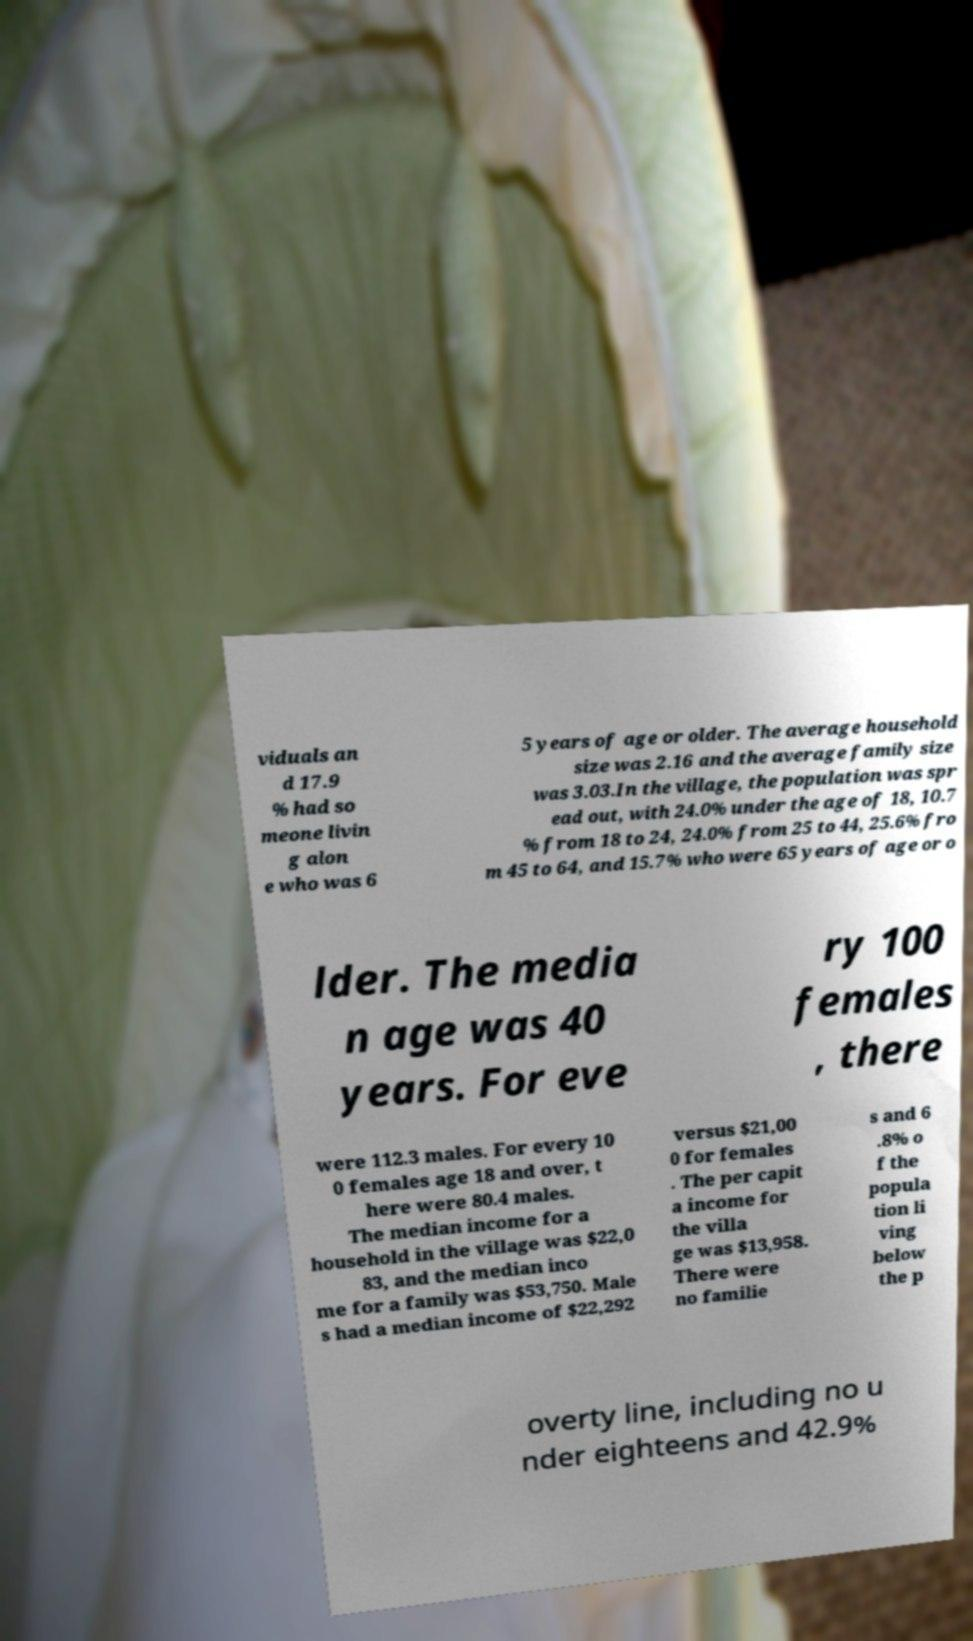There's text embedded in this image that I need extracted. Can you transcribe it verbatim? viduals an d 17.9 % had so meone livin g alon e who was 6 5 years of age or older. The average household size was 2.16 and the average family size was 3.03.In the village, the population was spr ead out, with 24.0% under the age of 18, 10.7 % from 18 to 24, 24.0% from 25 to 44, 25.6% fro m 45 to 64, and 15.7% who were 65 years of age or o lder. The media n age was 40 years. For eve ry 100 females , there were 112.3 males. For every 10 0 females age 18 and over, t here were 80.4 males. The median income for a household in the village was $22,0 83, and the median inco me for a family was $53,750. Male s had a median income of $22,292 versus $21,00 0 for females . The per capit a income for the villa ge was $13,958. There were no familie s and 6 .8% o f the popula tion li ving below the p overty line, including no u nder eighteens and 42.9% 